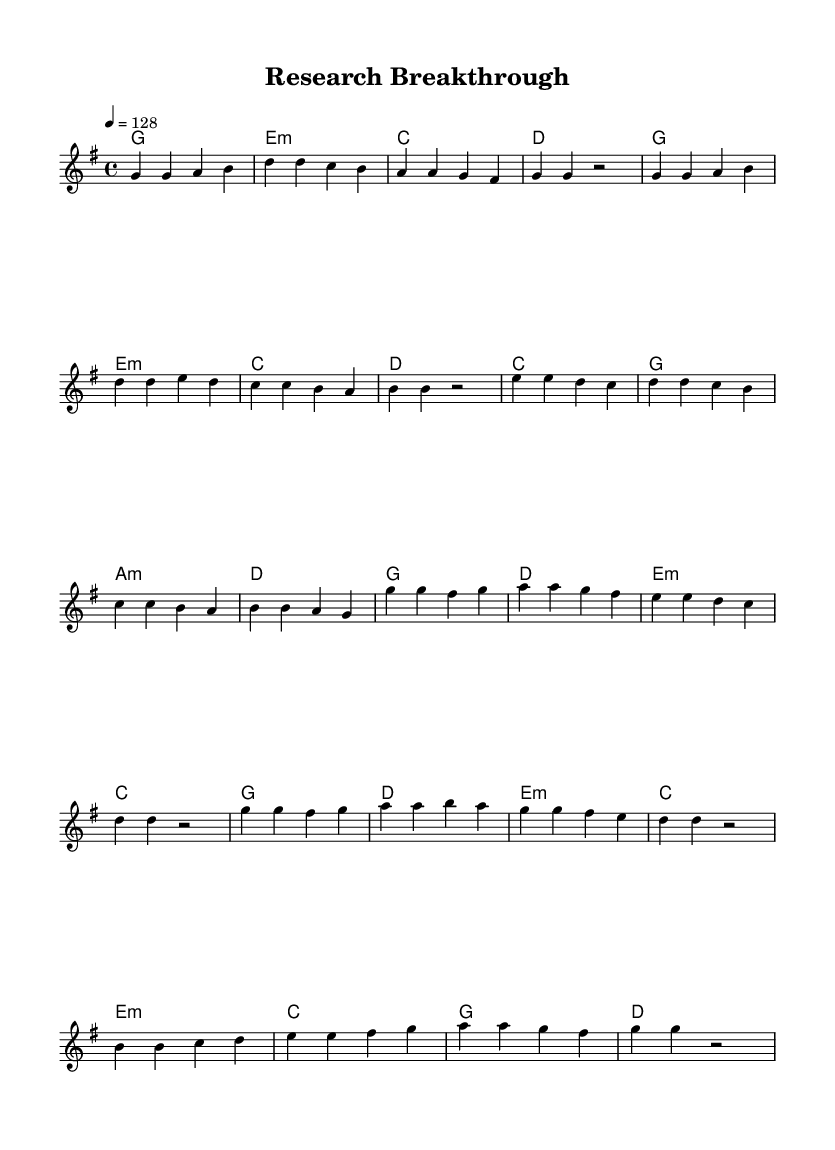What is the key signature of this music? The key signature is G major, which has one sharp (F-sharp). This can be determined by looking at the key signature indicated at the beginning of the score.
Answer: G major What is the time signature of this piece? The time signature is 4/4, indicating that there are four beats in each measure and the quarter note gets one beat. This is visually evident from the time signature shown at the beginning of the score.
Answer: 4/4 What is the tempo marking for this music? The tempo marking is 128 beats per minute, indicated by the tempo instruction in the score. This points to a moderately fast pace, common in upbeat K-Pop tracks.
Answer: 128 How many measures are in the chorus section? The chorus section consists of 8 measures, which can be counted by looking at the number of bar lines in that specific section of the score.
Answer: 8 What is the first note in the pre-chorus? The first note in the pre-chorus is E, found at the beginning of the pre-chorus section indicated in the score.
Answer: E Which chord follows the first measure of the bridge? The chord that follows the first measure of the bridge is C major, as shown in the chord changes written above the melody in the score.
Answer: C What is a notable thematic element reflected in the lyrics of this K-Pop track? The lyrics focus on overcoming challenges in academic research, a common theme for K-Pop songs that relate to personal growth and resilience. This is inferred from the description of the track's subject matter.
Answer: Overcoming challenges 